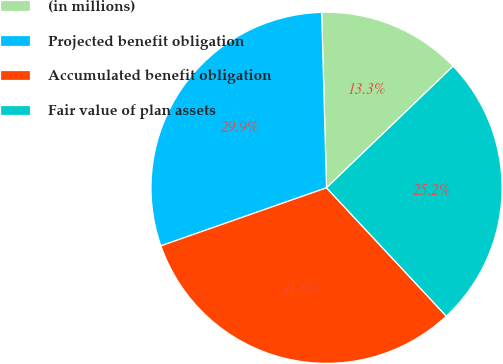Convert chart to OTSL. <chart><loc_0><loc_0><loc_500><loc_500><pie_chart><fcel>(in millions)<fcel>Projected benefit obligation<fcel>Accumulated benefit obligation<fcel>Fair value of plan assets<nl><fcel>13.26%<fcel>29.92%<fcel>31.59%<fcel>25.23%<nl></chart> 